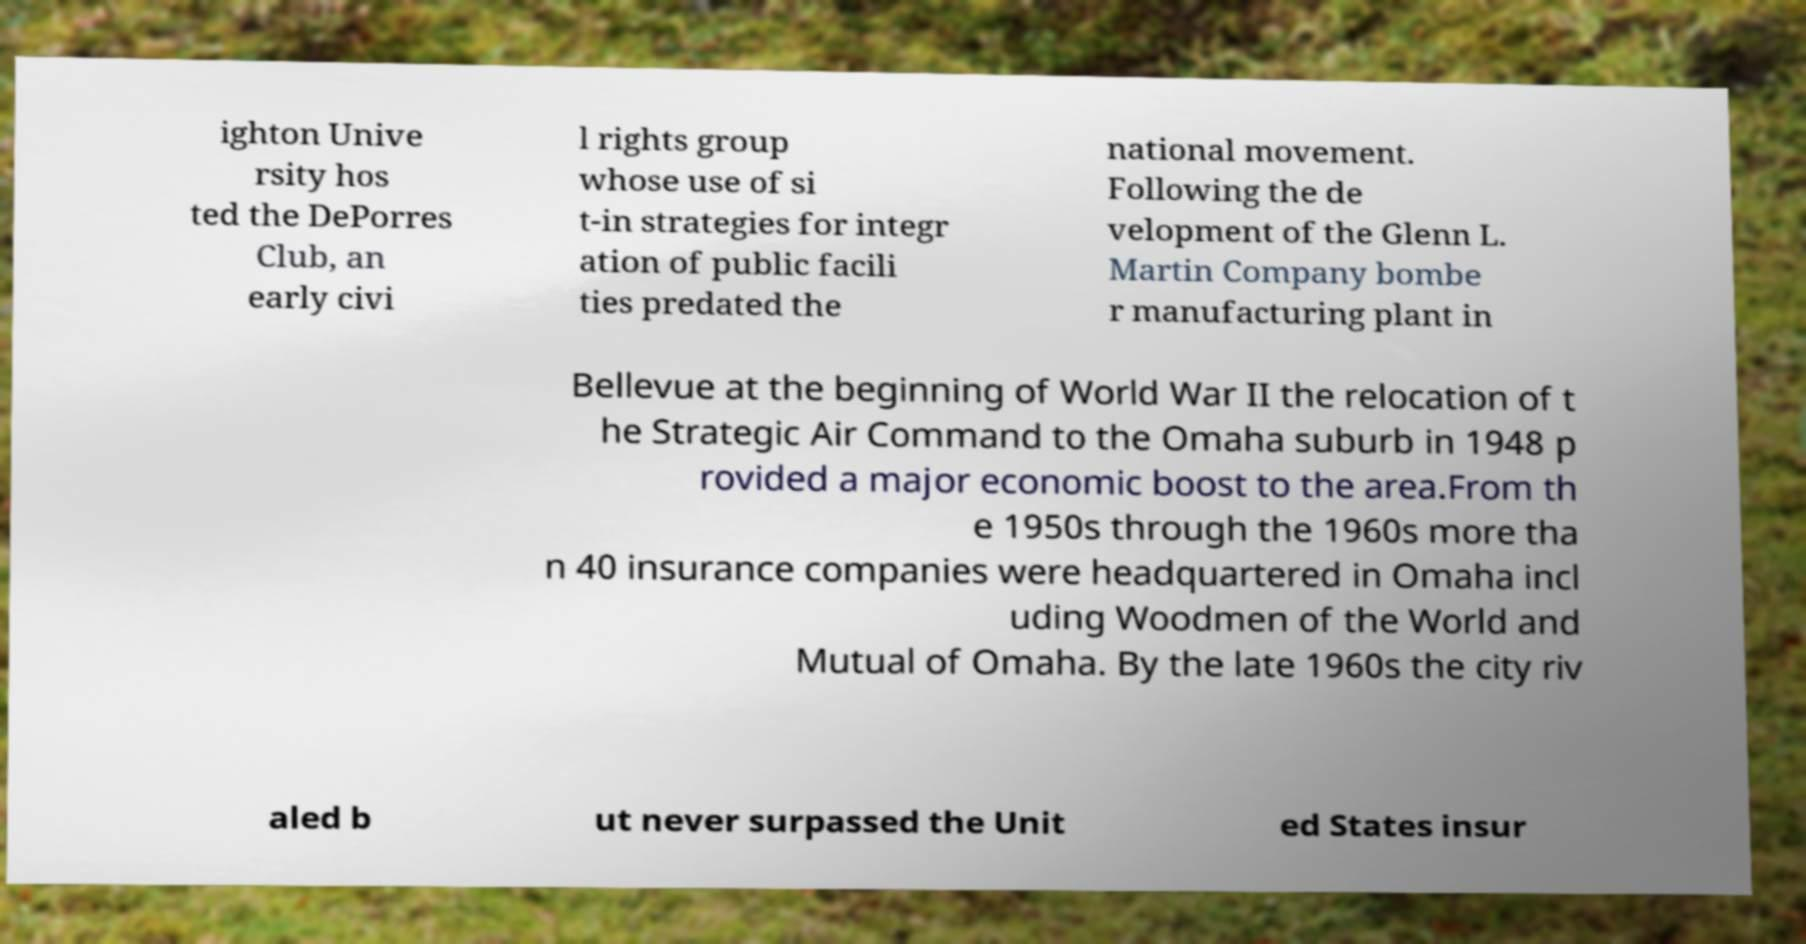Please read and relay the text visible in this image. What does it say? ighton Unive rsity hos ted the DePorres Club, an early civi l rights group whose use of si t-in strategies for integr ation of public facili ties predated the national movement. Following the de velopment of the Glenn L. Martin Company bombe r manufacturing plant in Bellevue at the beginning of World War II the relocation of t he Strategic Air Command to the Omaha suburb in 1948 p rovided a major economic boost to the area.From th e 1950s through the 1960s more tha n 40 insurance companies were headquartered in Omaha incl uding Woodmen of the World and Mutual of Omaha. By the late 1960s the city riv aled b ut never surpassed the Unit ed States insur 